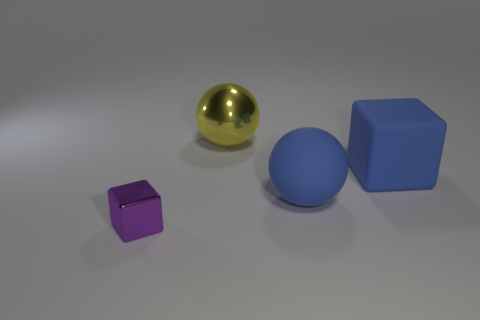What number of other objects are the same size as the yellow thing?
Ensure brevity in your answer.  2. Is there a tiny ball of the same color as the big metallic thing?
Provide a short and direct response. No. How many small things are matte spheres or yellow metallic spheres?
Provide a short and direct response. 0. What number of large green shiny cylinders are there?
Your response must be concise. 0. What is the material of the cube that is on the left side of the yellow sphere?
Your answer should be very brief. Metal. Are there any blue matte blocks behind the big blue matte cube?
Make the answer very short. No. Do the blue matte sphere and the purple object have the same size?
Keep it short and to the point. No. How many big yellow balls have the same material as the tiny cube?
Provide a short and direct response. 1. There is a cube that is behind the metallic object in front of the yellow metal sphere; how big is it?
Make the answer very short. Large. There is a big thing that is both to the left of the blue cube and behind the big blue ball; what is its color?
Give a very brief answer. Yellow. 